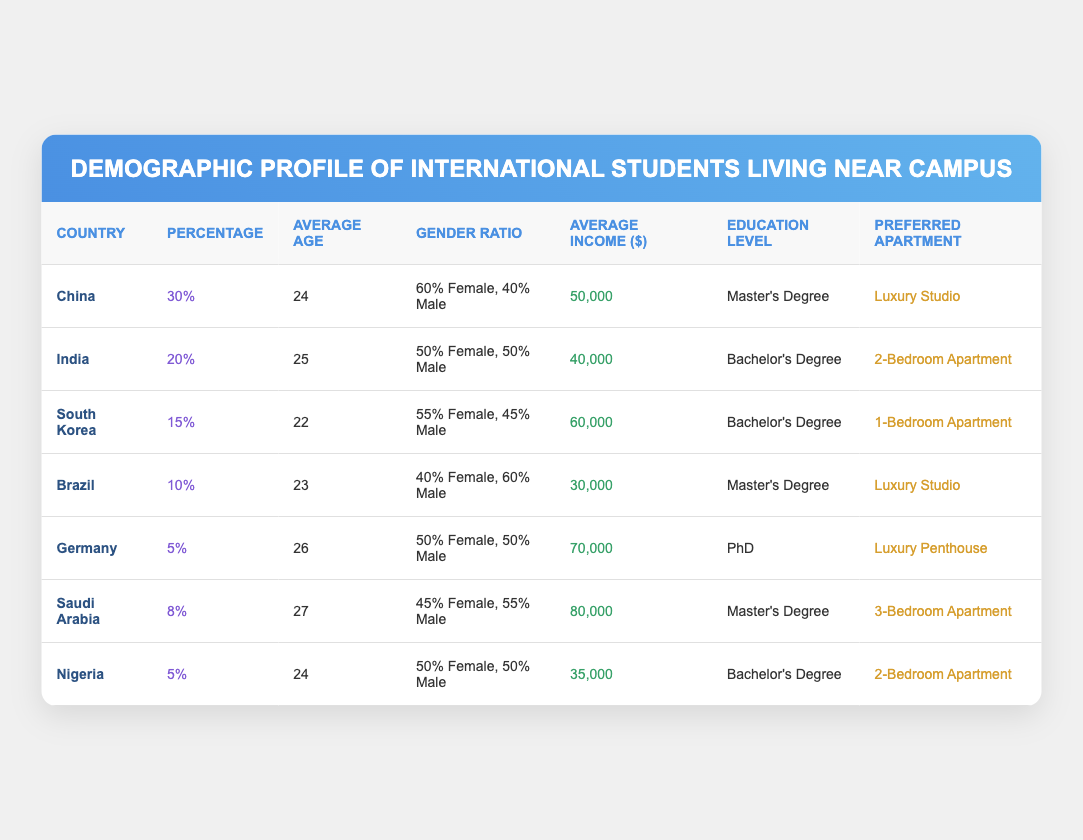What is the average income of international students from China? The average income listed for international students from China is $50,000.
Answer: $50,000 Which country has the highest percentage of students living near campus? According to the table, China has the highest percentage at 30%.
Answer: China How many countries listed have an average age of 24 or younger? The countries with an average age of 24 or younger are South Korea (22) and China (24), making a total of 2 countries.
Answer: 2 What is the gender ratio of international students from Saudi Arabia? The gender ratio for Saudi Arabian students is 45% Female and 55% Male, as per the table.
Answer: 45% Female, 55% Male Which country has the lowest average income, and what is that income? Brazil has the lowest average income, which is reported to be $30,000.
Answer: Brazil, $30,000 If you combine the percentages of international students from India and Nigeria, what is the total? The percentage of students from India is 20% and from Nigeria is 5%. Combining these gives a total of 25%.
Answer: 25% What is the preferred apartment type of international students from Germany? The preferred apartment type for students from Germany is a Luxury Penthouse.
Answer: Luxury Penthouse Are there any countries where the average income exceeds $70,000? Yes, Saudi Arabia and Germany each have average incomes that exceed $70,000—$80,000 and $70,000 respectively.
Answer: Yes Which country has the same education level as Brazil, and what is that education level? Brazil and China both have a Master's Degree as their education level.
Answer: China, Master's Degree What is the average age of students from South Korea? The average age of South Korean students is 22 years.
Answer: 22 If you consider the countries listed, what is the total percentage of students from China, Brazil, and Germany? The total percentage is calculated by adding China's 30%, Brazil's 10%, and Germany's 5%, resulting in 45%.
Answer: 45% 